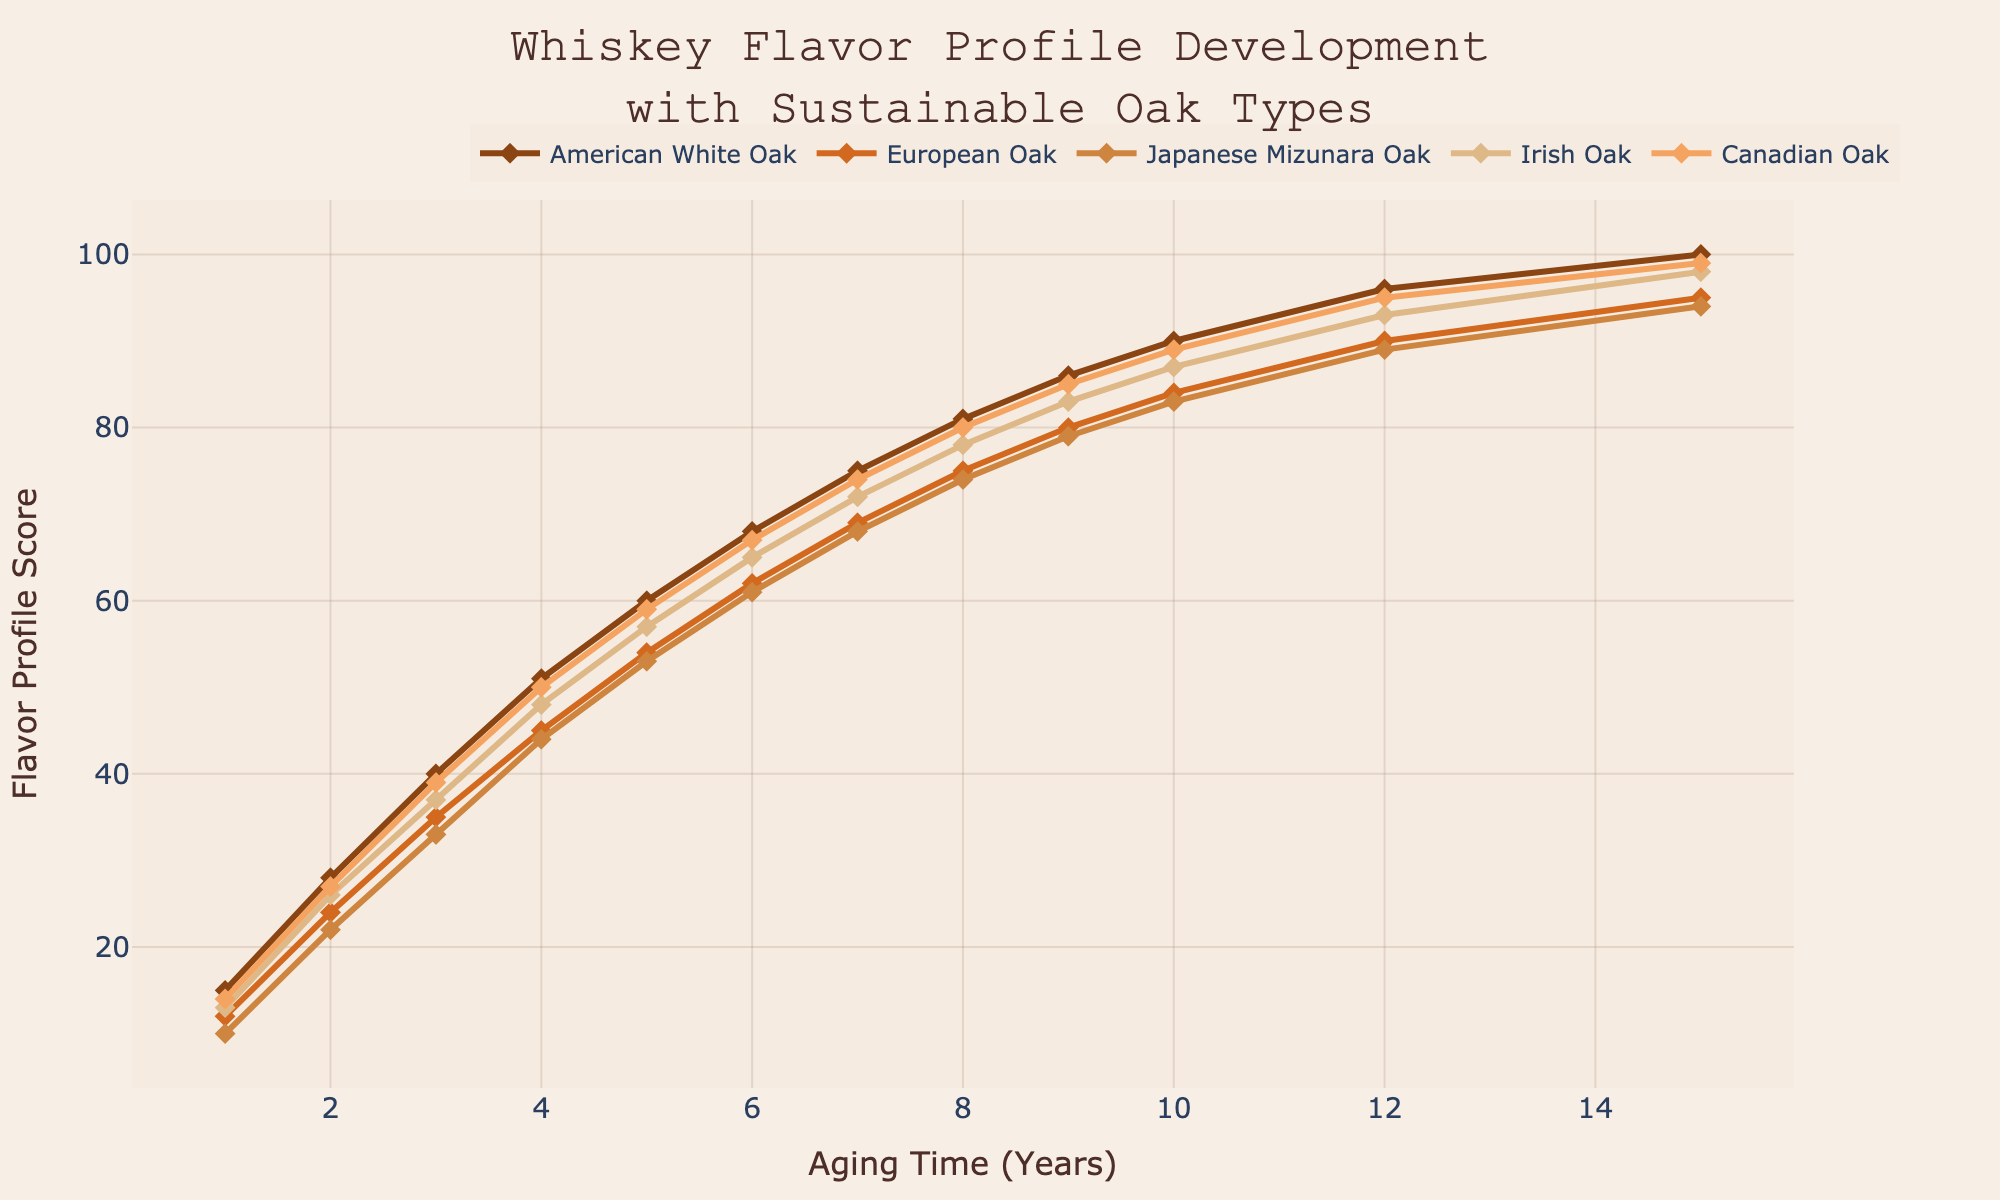How does the flavor profile score for American White Oak change over 10 years? To determine the change in flavor profile score for American White Oak, observe the scores at year 1 and year 10. At year 1, the score is 15, and at year 10, the score is 90. Therefore, the change is 90 - 15.
Answer: 75 Between which years does the flavor profile score for European Oak increase the most? Compare the changes in scores between successive years. From year 1 to 2 (12 to 24), year 2 to 3 (24 to 35), etc. The most significant increase is from year 1 to year 2, where the score goes from 12 to 24.
Answer: Year 1 to 2 By how much does the flavor profile score of Canadian Oak exceed that of Japanese Mizunara Oak at year 6? At year 6, the flavor profile score for Canadian Oak is 67, and for Japanese Mizunara Oak, it is 61. The difference is 67 - 61.
Answer: 6 Which oak type has the highest flavor profile score at year 15? Check the scores at year 15 for all oak types: American White Oak (100), European Oak (95), Japanese Mizunara Oak (94), Irish Oak (98), and Canadian Oak (99). American White Oak has the highest score.
Answer: American White Oak What is the average flavor profile score for Irish Oak over 15 years? To find the average score, sum the scores for Irish Oak across all the given years (13 + 26 + 37 + 48 + 57 + 65 + 72 + 78 + 83 + 87 + 93 + 98) and divide by 12. The sum is 757, and the average is 757 / 12.
Answer: 63.08 Are there any years where Japanese Mizunara Oak and European Oak have the same flavor profile score? Compare the scores for all years. At no point do Japanese Mizunara Oak and European Oak have the same scores. Japanese Mizunara Oak (10, 22, 33, 44, ... 94), European Oak (12, 24, 35, 45, ... 95).
Answer: No What is the total increase in flavor profile score of Irish Oak from year 1 to year 15? Find the score at year 1 (13) and year 15 (98), then calculate the difference: 98 - 13.
Answer: 85 Which oak type exhibits the steepest growth in flavor profile score between years 1 and 2? Calculate the increase in score from year 1 to 2 for each oak type. American White Oak (15 to 28, +13), European Oak (12 to 24, +12), Japanese Mizunara Oak (10 to 22, +12), Irish Oak (13 to 26, +13), Canadian Oak (14 to 27, +13). American White Oak, Irish Oak, and Canadian Oak show the steepest growth (+13).
Answer: American White Oak, Irish Oak, and Canadian Oak 